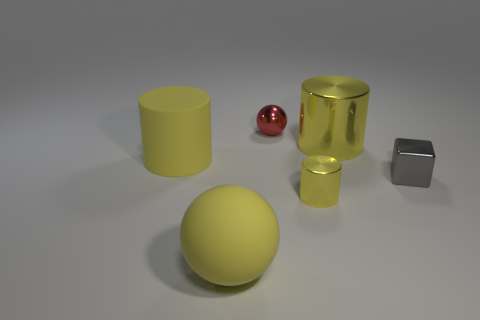Subtract all brown spheres. Subtract all red cylinders. How many spheres are left? 2 Add 1 big yellow metal cylinders. How many objects exist? 7 Subtract all spheres. How many objects are left? 4 Add 4 big objects. How many big objects are left? 7 Add 5 large blue rubber objects. How many large blue rubber objects exist? 5 Subtract 0 red cylinders. How many objects are left? 6 Subtract all small blue blocks. Subtract all large yellow things. How many objects are left? 3 